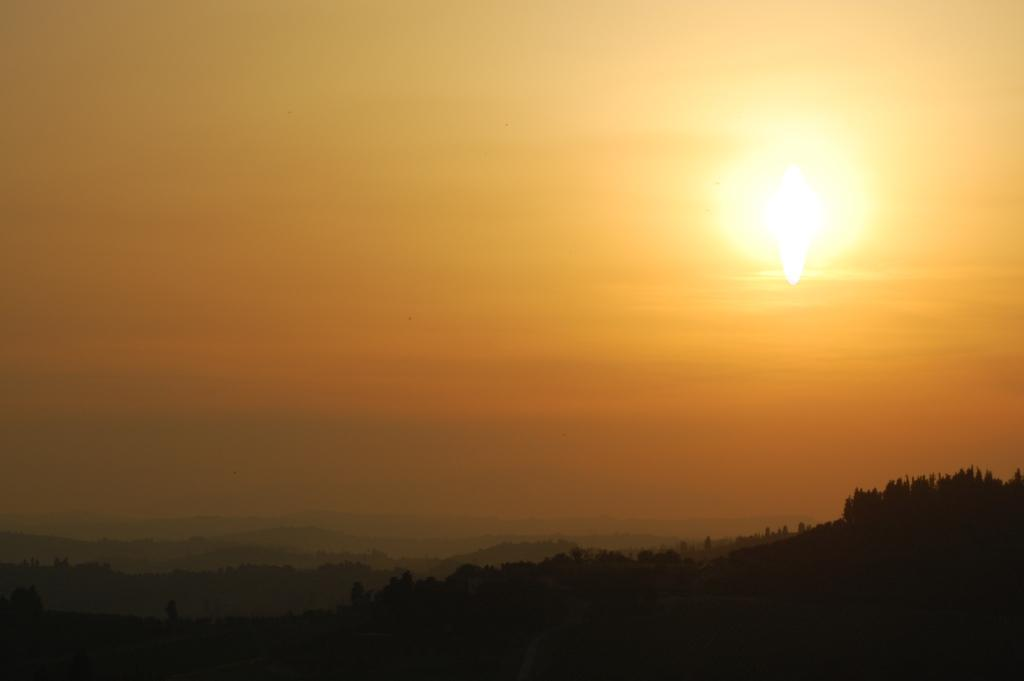What type of vegetation is present at the bottom of the image? There are trees at the bottom of the image. What can be seen in the background of the image? The sky is visible in the background of the image. What celestial body is observable in the sky? The sun is observable in the sky. What type of pie is being served in the image? There is no pie present in the image; it features trees and the sky. What type of juice is being consumed by the people in the image? There are no people or juice present in the image. 